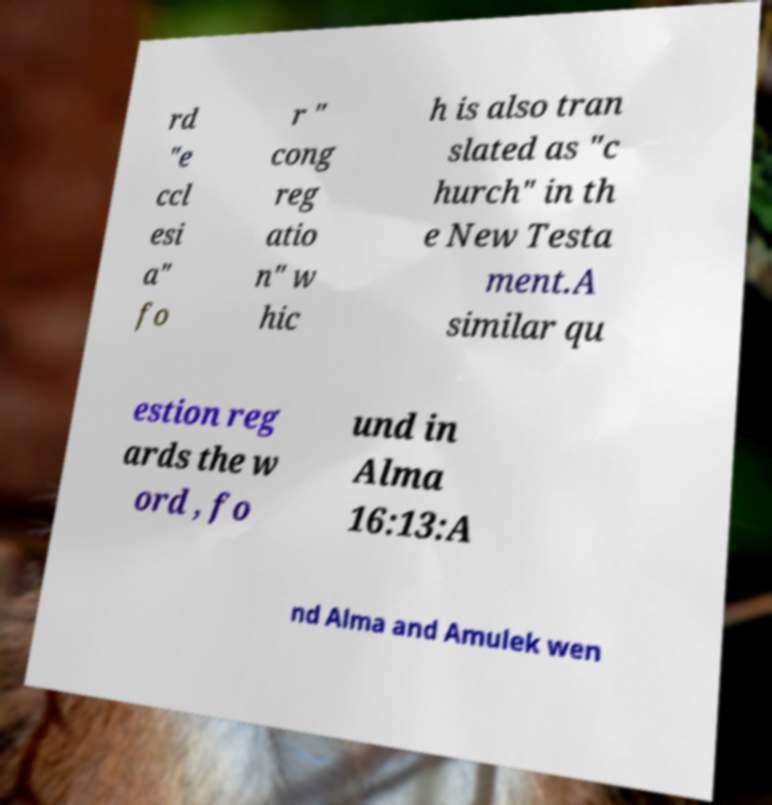There's text embedded in this image that I need extracted. Can you transcribe it verbatim? rd "e ccl esi a" fo r " cong reg atio n" w hic h is also tran slated as "c hurch" in th e New Testa ment.A similar qu estion reg ards the w ord , fo und in Alma 16:13:A nd Alma and Amulek wen 